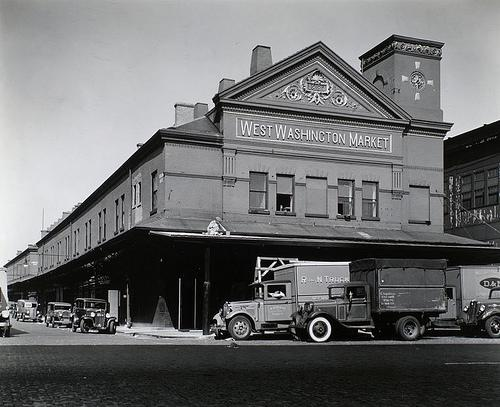Where are the trucks headed to?

Choices:
A) port
B) interstate
C) market
D) junkyard market 